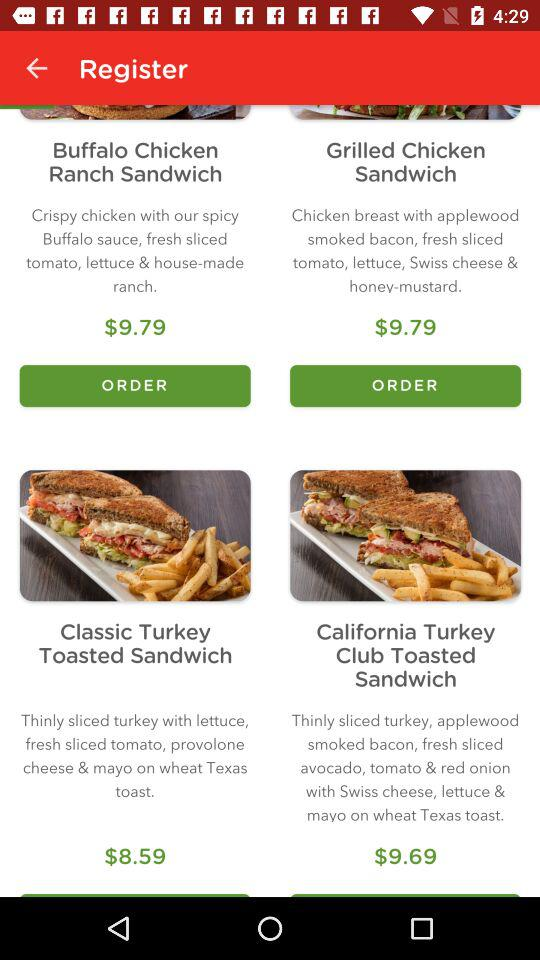Which item has a price of $8.59? The item is the Classic Turkey Toasted Sandwich. 